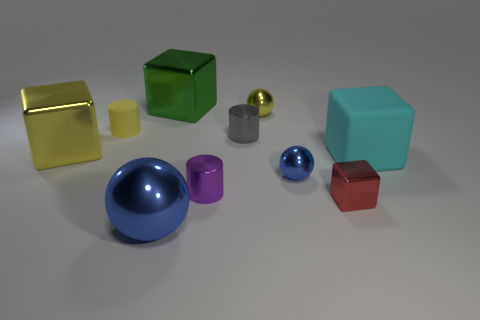Subtract all big yellow shiny cubes. How many cubes are left? 3 Subtract all purple cubes. Subtract all gray cylinders. How many cubes are left? 4 Subtract all cylinders. How many objects are left? 7 Add 9 yellow cubes. How many yellow cubes are left? 10 Add 2 large green things. How many large green things exist? 3 Subtract 1 blue spheres. How many objects are left? 9 Subtract all yellow things. Subtract all cylinders. How many objects are left? 4 